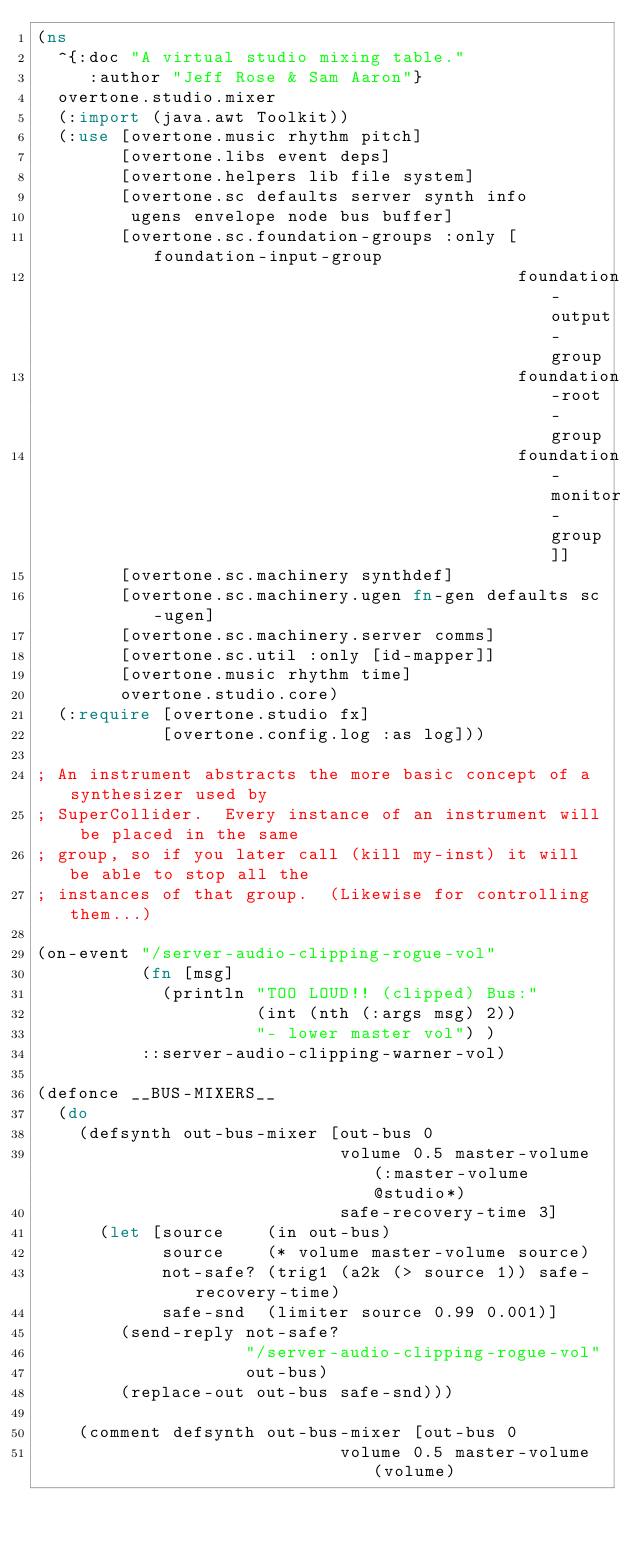<code> <loc_0><loc_0><loc_500><loc_500><_Clojure_>(ns
  ^{:doc "A virtual studio mixing table."
     :author "Jeff Rose & Sam Aaron"}
  overtone.studio.mixer
  (:import (java.awt Toolkit))
  (:use [overtone.music rhythm pitch]
        [overtone.libs event deps]
        [overtone.helpers lib file system]
        [overtone.sc defaults server synth info
         ugens envelope node bus buffer]
        [overtone.sc.foundation-groups :only [foundation-input-group
                                              foundation-output-group
                                              foundation-root-group
                                              foundation-monitor-group]]
        [overtone.sc.machinery synthdef]
        [overtone.sc.machinery.ugen fn-gen defaults sc-ugen]
        [overtone.sc.machinery.server comms]
        [overtone.sc.util :only [id-mapper]]
        [overtone.music rhythm time]
        overtone.studio.core)
  (:require [overtone.studio fx]
            [overtone.config.log :as log]))

; An instrument abstracts the more basic concept of a synthesizer used by
; SuperCollider.  Every instance of an instrument will be placed in the same
; group, so if you later call (kill my-inst) it will be able to stop all the
; instances of that group.  (Likewise for controlling them...)

(on-event "/server-audio-clipping-rogue-vol"
          (fn [msg]
            (println "TOO LOUD!! (clipped) Bus:"
                     (int (nth (:args msg) 2))
                     "- lower master vol") )
          ::server-audio-clipping-warner-vol)

(defonce __BUS-MIXERS__
  (do
    (defsynth out-bus-mixer [out-bus 0
                             volume 0.5 master-volume (:master-volume @studio*)
                             safe-recovery-time 3]
      (let [source    (in out-bus)
            source    (* volume master-volume source)
            not-safe? (trig1 (a2k (> source 1)) safe-recovery-time)
            safe-snd  (limiter source 0.99 0.001)]
        (send-reply not-safe?
                    "/server-audio-clipping-rogue-vol"
                    out-bus)
        (replace-out out-bus safe-snd)))

    (comment defsynth out-bus-mixer [out-bus 0
                             volume 0.5 master-volume (volume)</code> 